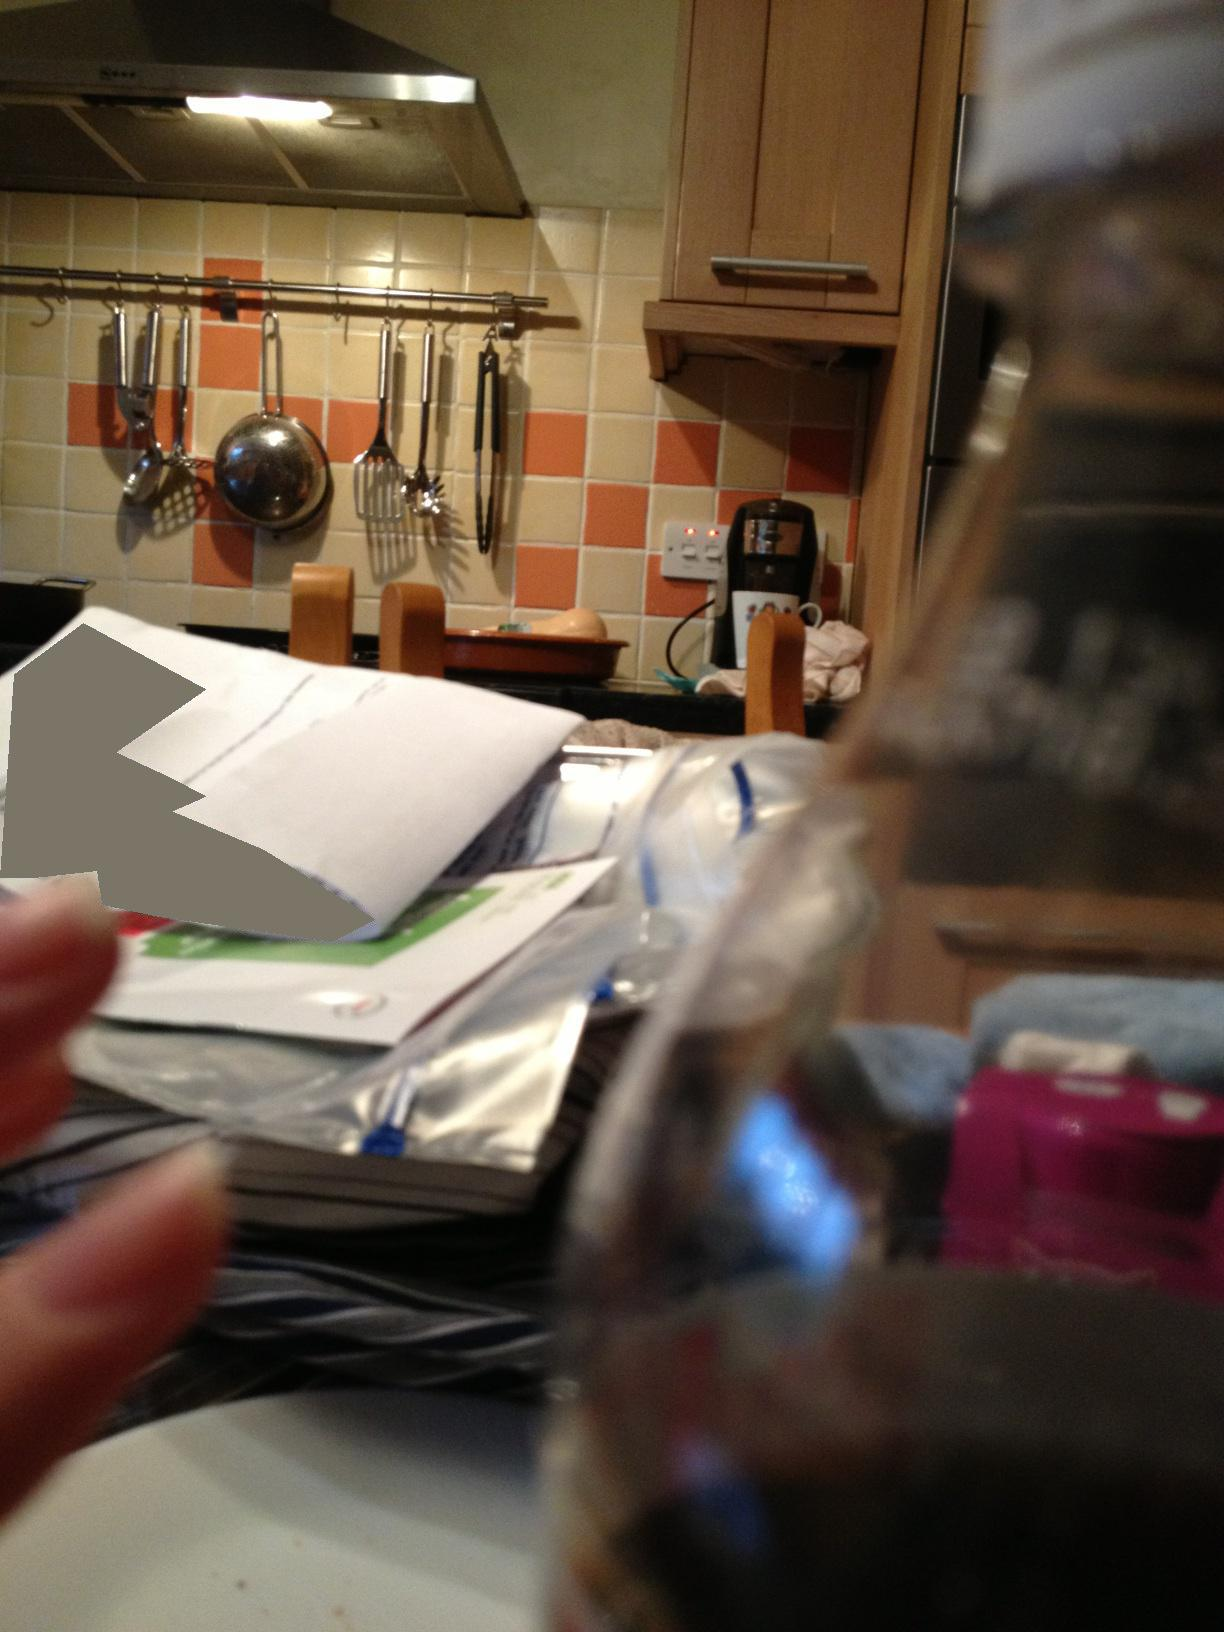What is this? from Vizwiz kitchen 